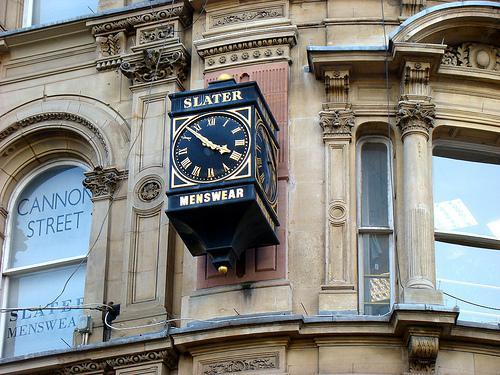Question: what is the time?
Choices:
A. 2:30.
B. 3:48 pm.
C. 2:20.
D. 1:15.
Answer with the letter. Answer: B Question: what is the street?
Choices:
A. Main.
B. Cannon.
C. 1st Ave.
D. 2nd Ave.
Answer with the letter. Answer: B Question: what color are the numbers on the clock?
Choices:
A. Black.
B. Golden.
C. White.
D. Red.
Answer with the letter. Answer: B 